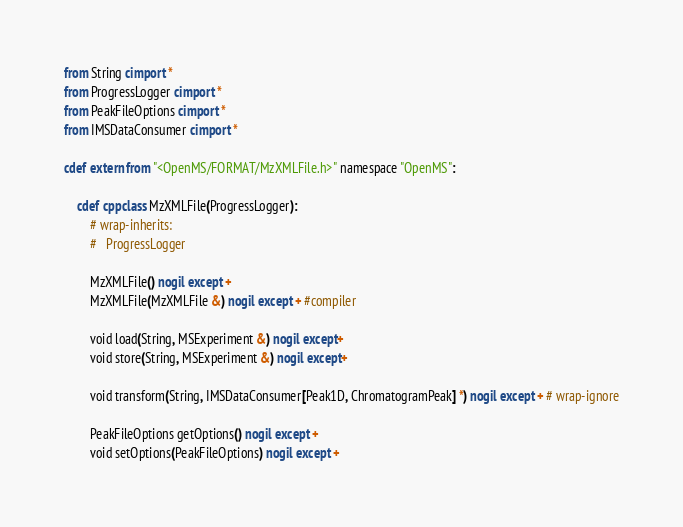Convert code to text. <code><loc_0><loc_0><loc_500><loc_500><_Cython_>from String cimport *
from ProgressLogger cimport *
from PeakFileOptions cimport *
from IMSDataConsumer cimport *

cdef extern from "<OpenMS/FORMAT/MzXMLFile.h>" namespace "OpenMS":

    cdef cppclass MzXMLFile(ProgressLogger):
        # wrap-inherits:
        #   ProgressLogger

        MzXMLFile() nogil except +
        MzXMLFile(MzXMLFile &) nogil except + #compiler

        void load(String, MSExperiment &) nogil except+
        void store(String, MSExperiment &) nogil except+

        void transform(String, IMSDataConsumer[Peak1D, ChromatogramPeak] *) nogil except + # wrap-ignore

        PeakFileOptions getOptions() nogil except +
        void setOptions(PeakFileOptions) nogil except +
</code> 